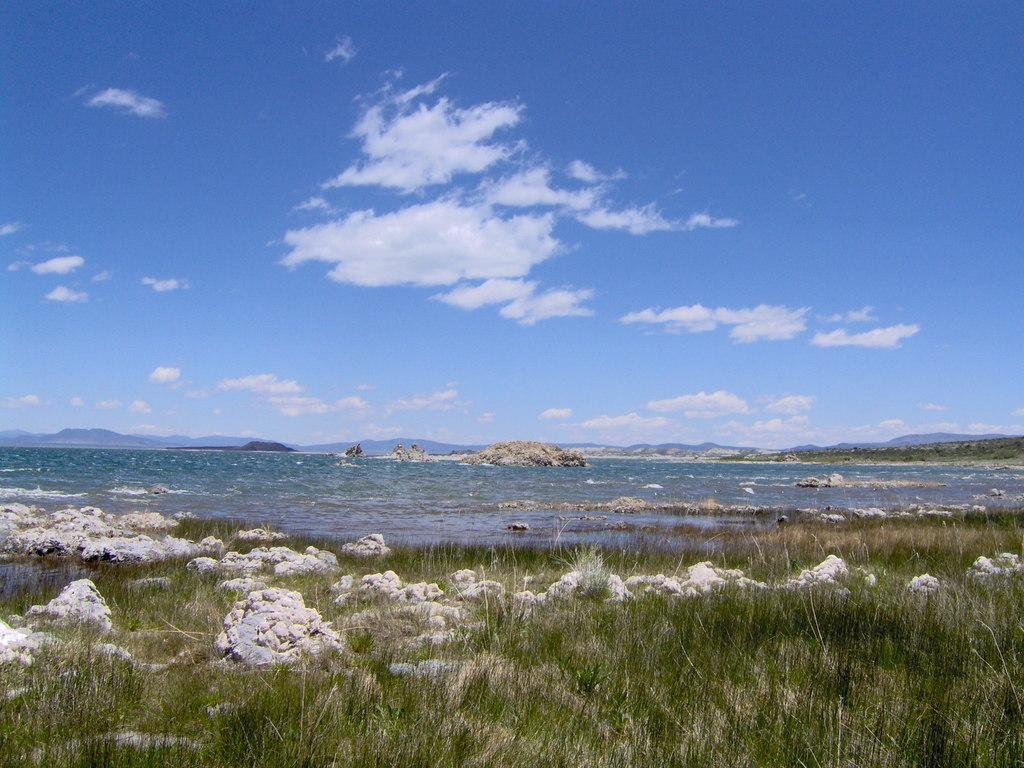What type of living organisms can be seen in the image? Plants can be seen in the image. What other elements are present in the image besides plants? There are rocks in the image. What can be seen in the background of the image? Water and the sky are visible in the background of the image. What is the condition of the sky in the image? Clouds are present in the sky. Can you tell me if the existence of the crook is confirmed in the image? There is no crook present in the image. Is anyone swimming in the water visible in the background of the image? There is no indication of anyone swimming in the water visible in the background of the image. 